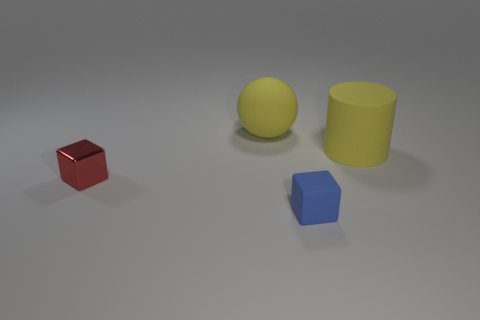How many small things are either matte cylinders or green metallic blocks?
Give a very brief answer. 0. What shape is the blue object that is the same material as the ball?
Your answer should be very brief. Cube. Does the tiny red object have the same shape as the tiny blue rubber object?
Keep it short and to the point. Yes. What color is the shiny object?
Provide a succinct answer. Red. What number of things are tiny cyan rubber cubes or rubber things?
Offer a terse response. 3. Are there any other things that have the same material as the red block?
Your response must be concise. No. Are there fewer large yellow cylinders that are behind the tiny shiny thing than big cylinders?
Offer a terse response. No. Is the number of yellow rubber things that are to the left of the small rubber object greater than the number of blue rubber things that are on the right side of the yellow matte cylinder?
Provide a short and direct response. Yes. Are there any other things that are the same color as the rubber cylinder?
Your response must be concise. Yes. What is the material of the small cube that is behind the tiny matte block?
Ensure brevity in your answer.  Metal. 